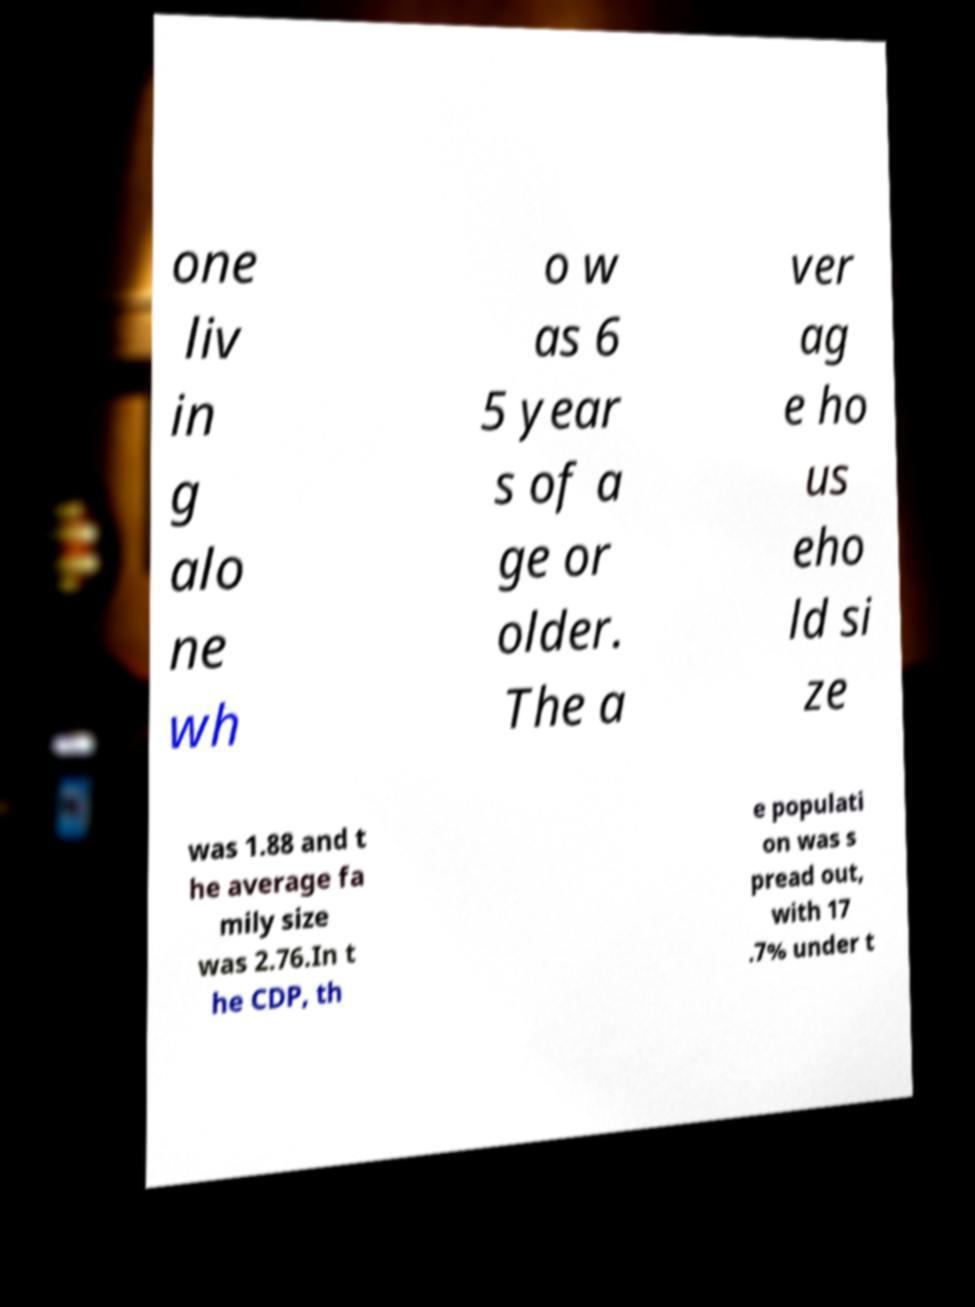For documentation purposes, I need the text within this image transcribed. Could you provide that? one liv in g alo ne wh o w as 6 5 year s of a ge or older. The a ver ag e ho us eho ld si ze was 1.88 and t he average fa mily size was 2.76.In t he CDP, th e populati on was s pread out, with 17 .7% under t 